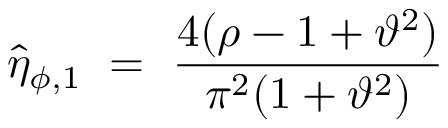Convert formula to latex. <formula><loc_0><loc_0><loc_500><loc_500>\hat { \eta } _ { \phi , 1 } = \frac { 4 ( \rho - 1 + \vartheta ^ { 2 } ) } { \pi ^ { 2 } ( 1 + \vartheta ^ { 2 } ) }</formula> 